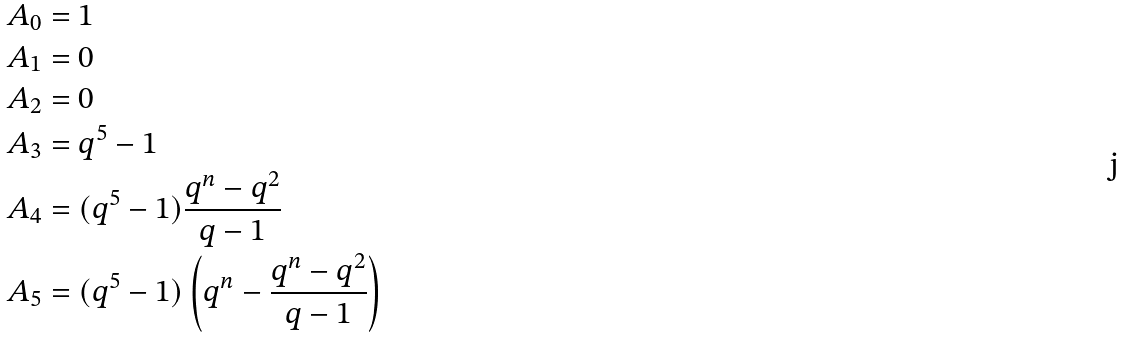Convert formula to latex. <formula><loc_0><loc_0><loc_500><loc_500>A _ { 0 } & = 1 \\ A _ { 1 } & = 0 \\ A _ { 2 } & = 0 \\ A _ { 3 } & = q ^ { 5 } - 1 \\ A _ { 4 } & = ( q ^ { 5 } - 1 ) \frac { q ^ { n } - q ^ { 2 } } { q - 1 } \\ A _ { 5 } & = ( q ^ { 5 } - 1 ) \left ( q ^ { n } - \frac { q ^ { n } - q ^ { 2 } } { q - 1 } \right )</formula> 